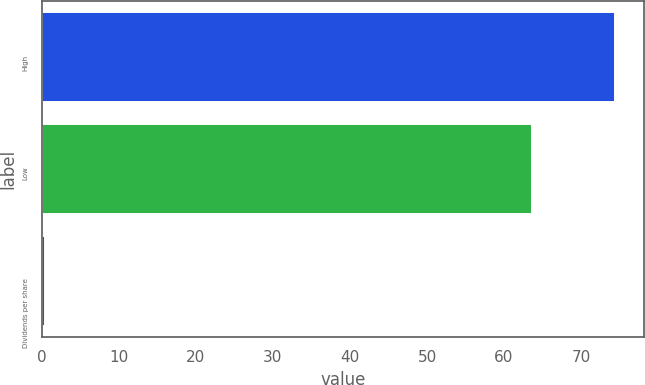Convert chart to OTSL. <chart><loc_0><loc_0><loc_500><loc_500><bar_chart><fcel>High<fcel>Low<fcel>Dividends per share<nl><fcel>74.41<fcel>63.67<fcel>0.47<nl></chart> 